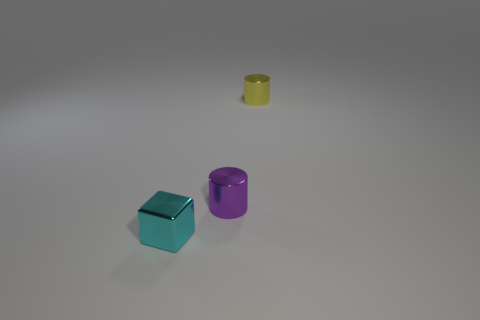Add 2 tiny brown things. How many objects exist? 5 Subtract all cylinders. How many objects are left? 1 Subtract all small blue rubber cubes. Subtract all tiny cylinders. How many objects are left? 1 Add 1 tiny yellow shiny objects. How many tiny yellow shiny objects are left? 2 Add 1 yellow shiny cylinders. How many yellow shiny cylinders exist? 2 Subtract 0 gray balls. How many objects are left? 3 